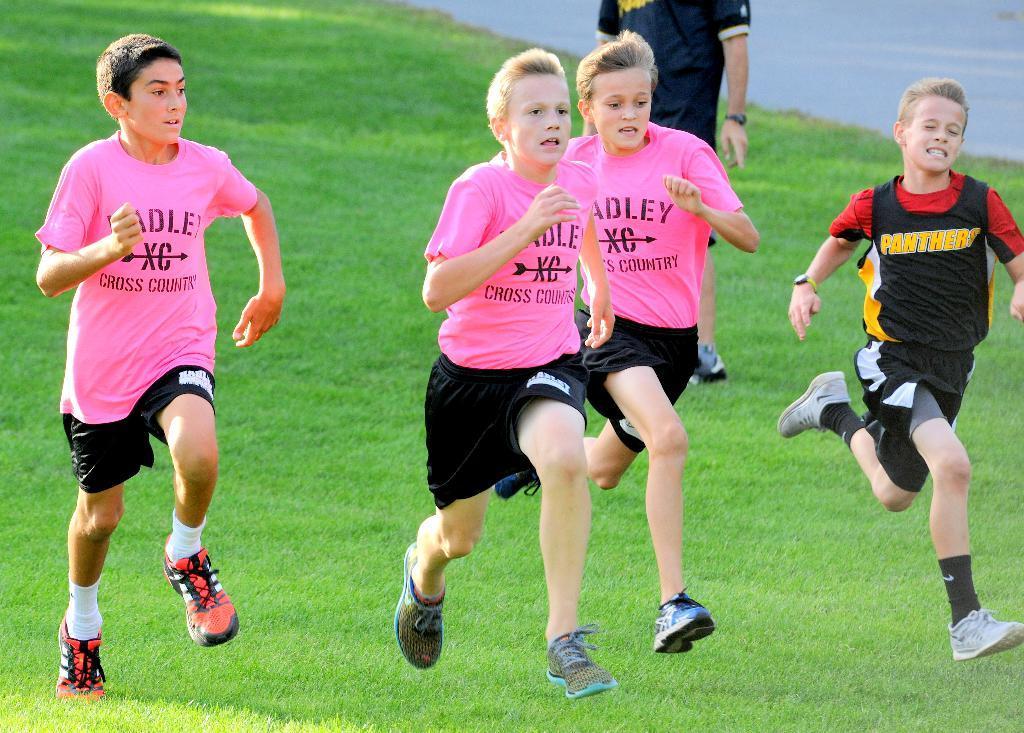How would you summarize this image in a sentence or two? In this image we can see four persons running on the grassy land. Behind the persons we can see a person standing. In the top right, we can see the road. 